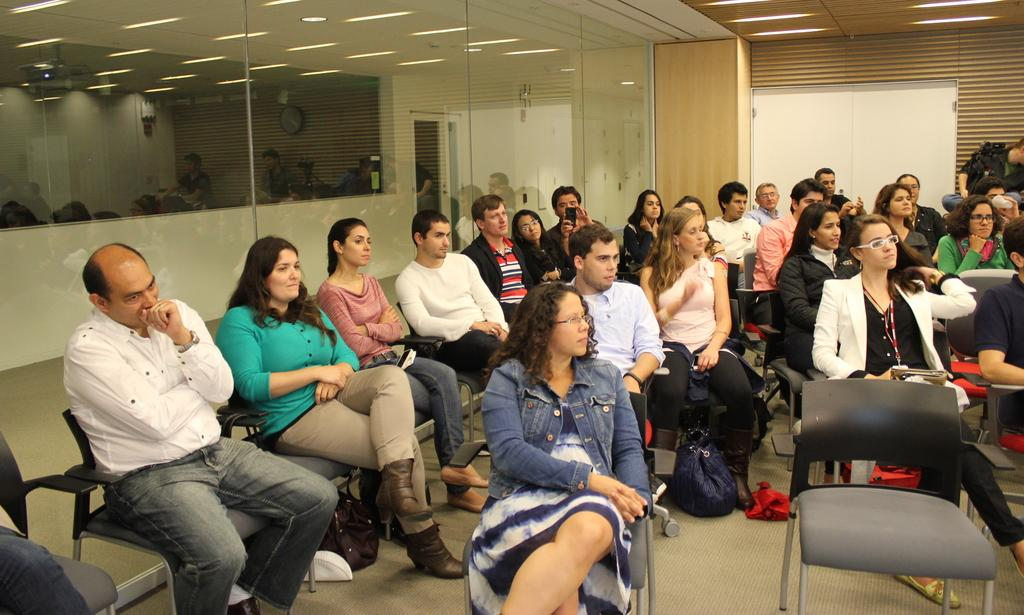Where was the image taken? The image was taken in a room. What are the people in the image doing? There are many people sitting on chairs in the center of the room. What can be seen in the background of the room? There is a door in the background of the room. What is providing light in the room? There are lights at the top of the room. How many children are laughing in the image? There are no children or laughter present in the image; it shows people sitting on chairs in a room. 